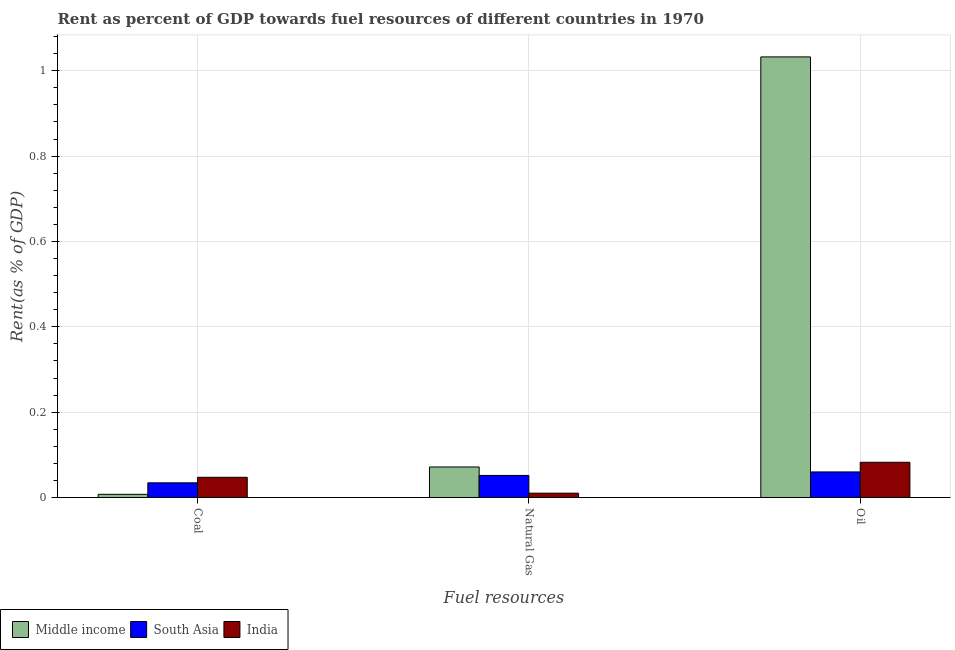How many different coloured bars are there?
Give a very brief answer. 3. Are the number of bars per tick equal to the number of legend labels?
Your answer should be compact. Yes. Are the number of bars on each tick of the X-axis equal?
Offer a very short reply. Yes. What is the label of the 3rd group of bars from the left?
Offer a very short reply. Oil. What is the rent towards coal in South Asia?
Offer a terse response. 0.03. Across all countries, what is the maximum rent towards oil?
Make the answer very short. 1.03. Across all countries, what is the minimum rent towards natural gas?
Your answer should be very brief. 0.01. In which country was the rent towards oil minimum?
Keep it short and to the point. South Asia. What is the total rent towards coal in the graph?
Provide a succinct answer. 0.09. What is the difference between the rent towards coal in India and that in Middle income?
Provide a succinct answer. 0.04. What is the difference between the rent towards natural gas in India and the rent towards coal in Middle income?
Provide a short and direct response. 0. What is the average rent towards oil per country?
Your response must be concise. 0.39. What is the difference between the rent towards oil and rent towards natural gas in South Asia?
Offer a terse response. 0.01. What is the ratio of the rent towards coal in South Asia to that in Middle income?
Ensure brevity in your answer.  4.63. Is the rent towards natural gas in South Asia less than that in India?
Provide a succinct answer. No. What is the difference between the highest and the second highest rent towards coal?
Give a very brief answer. 0.01. What is the difference between the highest and the lowest rent towards natural gas?
Provide a succinct answer. 0.06. What does the 3rd bar from the left in Oil represents?
Ensure brevity in your answer.  India. What does the 3rd bar from the right in Oil represents?
Offer a terse response. Middle income. What is the difference between two consecutive major ticks on the Y-axis?
Ensure brevity in your answer.  0.2. Does the graph contain any zero values?
Offer a terse response. No. Where does the legend appear in the graph?
Offer a very short reply. Bottom left. How many legend labels are there?
Provide a succinct answer. 3. What is the title of the graph?
Make the answer very short. Rent as percent of GDP towards fuel resources of different countries in 1970. What is the label or title of the X-axis?
Offer a terse response. Fuel resources. What is the label or title of the Y-axis?
Keep it short and to the point. Rent(as % of GDP). What is the Rent(as % of GDP) of Middle income in Coal?
Your answer should be compact. 0.01. What is the Rent(as % of GDP) of South Asia in Coal?
Give a very brief answer. 0.03. What is the Rent(as % of GDP) of India in Coal?
Make the answer very short. 0.05. What is the Rent(as % of GDP) of Middle income in Natural Gas?
Provide a short and direct response. 0.07. What is the Rent(as % of GDP) in South Asia in Natural Gas?
Ensure brevity in your answer.  0.05. What is the Rent(as % of GDP) in India in Natural Gas?
Offer a terse response. 0.01. What is the Rent(as % of GDP) in Middle income in Oil?
Your response must be concise. 1.03. What is the Rent(as % of GDP) of South Asia in Oil?
Offer a very short reply. 0.06. What is the Rent(as % of GDP) in India in Oil?
Keep it short and to the point. 0.08. Across all Fuel resources, what is the maximum Rent(as % of GDP) in Middle income?
Offer a terse response. 1.03. Across all Fuel resources, what is the maximum Rent(as % of GDP) of South Asia?
Provide a succinct answer. 0.06. Across all Fuel resources, what is the maximum Rent(as % of GDP) in India?
Provide a succinct answer. 0.08. Across all Fuel resources, what is the minimum Rent(as % of GDP) of Middle income?
Make the answer very short. 0.01. Across all Fuel resources, what is the minimum Rent(as % of GDP) in South Asia?
Give a very brief answer. 0.03. Across all Fuel resources, what is the minimum Rent(as % of GDP) of India?
Your answer should be very brief. 0.01. What is the total Rent(as % of GDP) of Middle income in the graph?
Your answer should be compact. 1.11. What is the total Rent(as % of GDP) in South Asia in the graph?
Your response must be concise. 0.15. What is the total Rent(as % of GDP) in India in the graph?
Provide a succinct answer. 0.14. What is the difference between the Rent(as % of GDP) of Middle income in Coal and that in Natural Gas?
Make the answer very short. -0.06. What is the difference between the Rent(as % of GDP) of South Asia in Coal and that in Natural Gas?
Give a very brief answer. -0.02. What is the difference between the Rent(as % of GDP) of India in Coal and that in Natural Gas?
Offer a very short reply. 0.04. What is the difference between the Rent(as % of GDP) of Middle income in Coal and that in Oil?
Give a very brief answer. -1.02. What is the difference between the Rent(as % of GDP) in South Asia in Coal and that in Oil?
Offer a terse response. -0.03. What is the difference between the Rent(as % of GDP) of India in Coal and that in Oil?
Your answer should be very brief. -0.04. What is the difference between the Rent(as % of GDP) of Middle income in Natural Gas and that in Oil?
Your response must be concise. -0.96. What is the difference between the Rent(as % of GDP) in South Asia in Natural Gas and that in Oil?
Your answer should be compact. -0.01. What is the difference between the Rent(as % of GDP) in India in Natural Gas and that in Oil?
Offer a very short reply. -0.07. What is the difference between the Rent(as % of GDP) in Middle income in Coal and the Rent(as % of GDP) in South Asia in Natural Gas?
Give a very brief answer. -0.04. What is the difference between the Rent(as % of GDP) in Middle income in Coal and the Rent(as % of GDP) in India in Natural Gas?
Ensure brevity in your answer.  -0. What is the difference between the Rent(as % of GDP) of South Asia in Coal and the Rent(as % of GDP) of India in Natural Gas?
Keep it short and to the point. 0.02. What is the difference between the Rent(as % of GDP) of Middle income in Coal and the Rent(as % of GDP) of South Asia in Oil?
Offer a very short reply. -0.05. What is the difference between the Rent(as % of GDP) of Middle income in Coal and the Rent(as % of GDP) of India in Oil?
Provide a succinct answer. -0.08. What is the difference between the Rent(as % of GDP) in South Asia in Coal and the Rent(as % of GDP) in India in Oil?
Provide a short and direct response. -0.05. What is the difference between the Rent(as % of GDP) of Middle income in Natural Gas and the Rent(as % of GDP) of South Asia in Oil?
Keep it short and to the point. 0.01. What is the difference between the Rent(as % of GDP) of Middle income in Natural Gas and the Rent(as % of GDP) of India in Oil?
Keep it short and to the point. -0.01. What is the difference between the Rent(as % of GDP) in South Asia in Natural Gas and the Rent(as % of GDP) in India in Oil?
Keep it short and to the point. -0.03. What is the average Rent(as % of GDP) in Middle income per Fuel resources?
Your answer should be compact. 0.37. What is the average Rent(as % of GDP) of South Asia per Fuel resources?
Offer a very short reply. 0.05. What is the average Rent(as % of GDP) in India per Fuel resources?
Offer a terse response. 0.05. What is the difference between the Rent(as % of GDP) in Middle income and Rent(as % of GDP) in South Asia in Coal?
Your answer should be compact. -0.03. What is the difference between the Rent(as % of GDP) of Middle income and Rent(as % of GDP) of India in Coal?
Give a very brief answer. -0.04. What is the difference between the Rent(as % of GDP) of South Asia and Rent(as % of GDP) of India in Coal?
Your answer should be compact. -0.01. What is the difference between the Rent(as % of GDP) of Middle income and Rent(as % of GDP) of South Asia in Natural Gas?
Ensure brevity in your answer.  0.02. What is the difference between the Rent(as % of GDP) in Middle income and Rent(as % of GDP) in India in Natural Gas?
Your response must be concise. 0.06. What is the difference between the Rent(as % of GDP) in South Asia and Rent(as % of GDP) in India in Natural Gas?
Your answer should be compact. 0.04. What is the difference between the Rent(as % of GDP) of Middle income and Rent(as % of GDP) of South Asia in Oil?
Your answer should be very brief. 0.97. What is the difference between the Rent(as % of GDP) of Middle income and Rent(as % of GDP) of India in Oil?
Your answer should be compact. 0.95. What is the difference between the Rent(as % of GDP) of South Asia and Rent(as % of GDP) of India in Oil?
Provide a short and direct response. -0.02. What is the ratio of the Rent(as % of GDP) in Middle income in Coal to that in Natural Gas?
Provide a short and direct response. 0.1. What is the ratio of the Rent(as % of GDP) of South Asia in Coal to that in Natural Gas?
Give a very brief answer. 0.67. What is the ratio of the Rent(as % of GDP) in India in Coal to that in Natural Gas?
Your response must be concise. 4.68. What is the ratio of the Rent(as % of GDP) of Middle income in Coal to that in Oil?
Offer a terse response. 0.01. What is the ratio of the Rent(as % of GDP) of South Asia in Coal to that in Oil?
Your answer should be compact. 0.57. What is the ratio of the Rent(as % of GDP) in India in Coal to that in Oil?
Ensure brevity in your answer.  0.57. What is the ratio of the Rent(as % of GDP) of Middle income in Natural Gas to that in Oil?
Offer a terse response. 0.07. What is the ratio of the Rent(as % of GDP) of South Asia in Natural Gas to that in Oil?
Offer a terse response. 0.86. What is the ratio of the Rent(as % of GDP) of India in Natural Gas to that in Oil?
Provide a succinct answer. 0.12. What is the difference between the highest and the second highest Rent(as % of GDP) in Middle income?
Provide a short and direct response. 0.96. What is the difference between the highest and the second highest Rent(as % of GDP) in South Asia?
Keep it short and to the point. 0.01. What is the difference between the highest and the second highest Rent(as % of GDP) in India?
Keep it short and to the point. 0.04. What is the difference between the highest and the lowest Rent(as % of GDP) in Middle income?
Provide a short and direct response. 1.02. What is the difference between the highest and the lowest Rent(as % of GDP) in South Asia?
Your response must be concise. 0.03. What is the difference between the highest and the lowest Rent(as % of GDP) in India?
Ensure brevity in your answer.  0.07. 